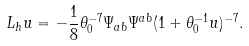Convert formula to latex. <formula><loc_0><loc_0><loc_500><loc_500>L _ { h } u = - \frac { 1 } { 8 } \theta _ { 0 } ^ { - 7 } \Psi _ { a b } \Psi ^ { a b } ( 1 + \theta _ { 0 } ^ { - 1 } u ) ^ { - 7 } .</formula> 